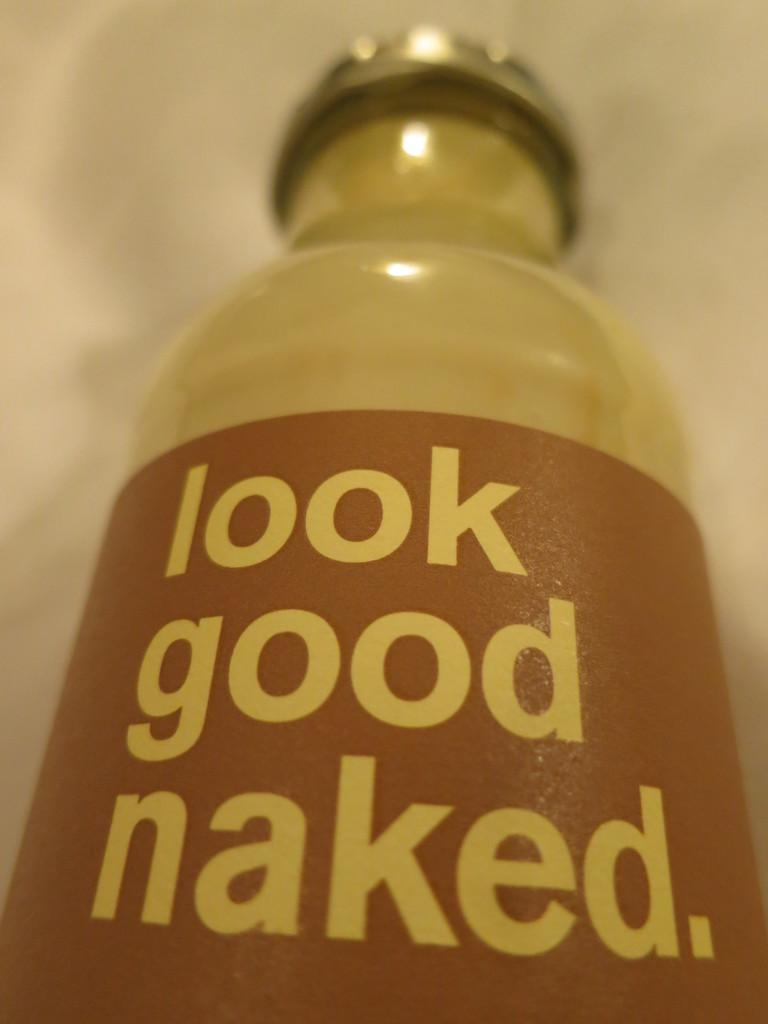<image>
Write a terse but informative summary of the picture. A bottle has the words look good naked on it. 